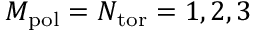Convert formula to latex. <formula><loc_0><loc_0><loc_500><loc_500>M _ { p o l } = N _ { t o r } = 1 , 2 , 3</formula> 